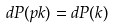Convert formula to latex. <formula><loc_0><loc_0><loc_500><loc_500>d P ( p k ) = d P ( k )</formula> 